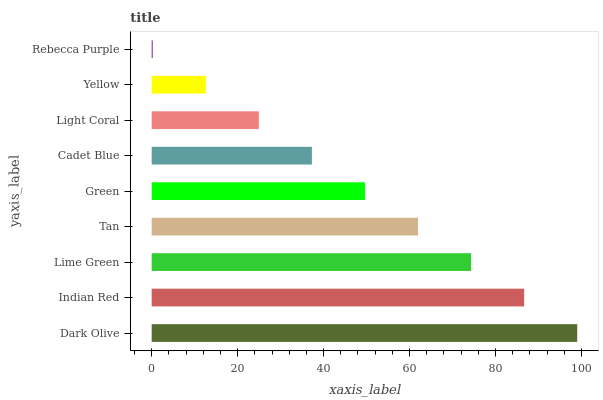Is Rebecca Purple the minimum?
Answer yes or no. Yes. Is Dark Olive the maximum?
Answer yes or no. Yes. Is Indian Red the minimum?
Answer yes or no. No. Is Indian Red the maximum?
Answer yes or no. No. Is Dark Olive greater than Indian Red?
Answer yes or no. Yes. Is Indian Red less than Dark Olive?
Answer yes or no. Yes. Is Indian Red greater than Dark Olive?
Answer yes or no. No. Is Dark Olive less than Indian Red?
Answer yes or no. No. Is Green the high median?
Answer yes or no. Yes. Is Green the low median?
Answer yes or no. Yes. Is Light Coral the high median?
Answer yes or no. No. Is Tan the low median?
Answer yes or no. No. 